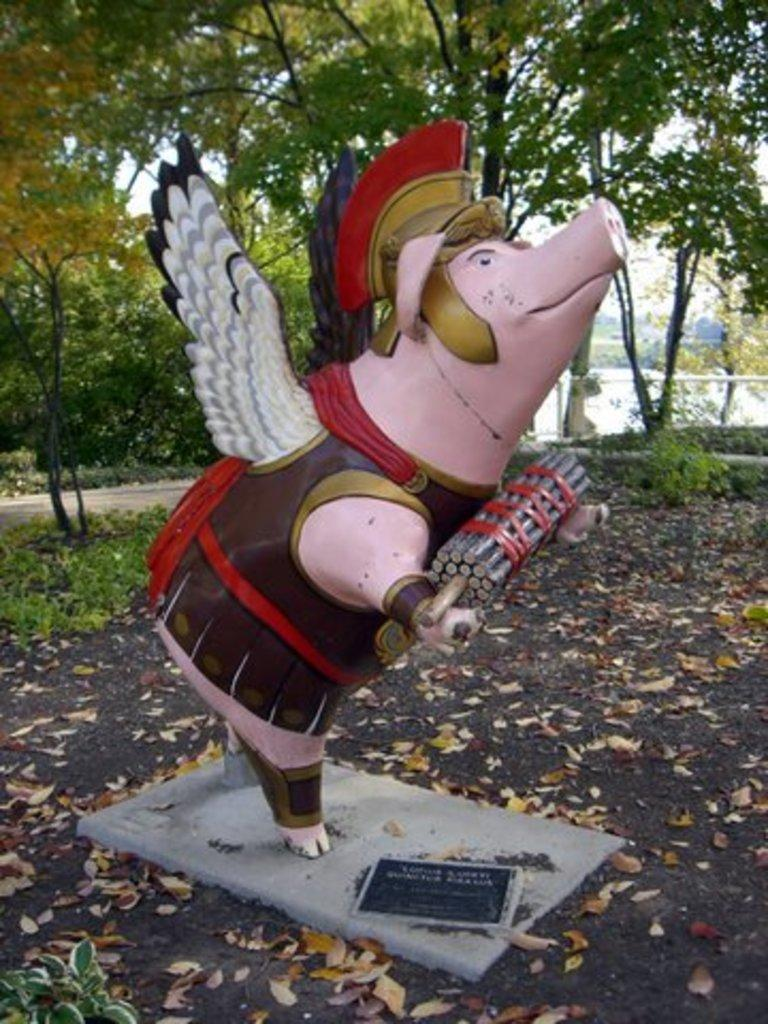What is the main subject of the image? There is a sculpture in the image. What can be found near the sculpture? There is a name board in the image. What is on the ground around the sculpture? Shredded leaves are present on the ground. What type of vegetation is visible in the image? Shrubs and trees are visible in the image. What type of pathway is present in the image? There is a road in the image. What part of the natural environment is visible in the image? The sky is visible in the image. What type of government is depicted in the sculpture? The sculpture does not depict a government; it is a standalone artwork. What is the purpose of the point in the image? There is no specific point mentioned in the image; the conversation focuses on the sculpture, name board, shredded leaves, shrubs, trees, road, and sky. 